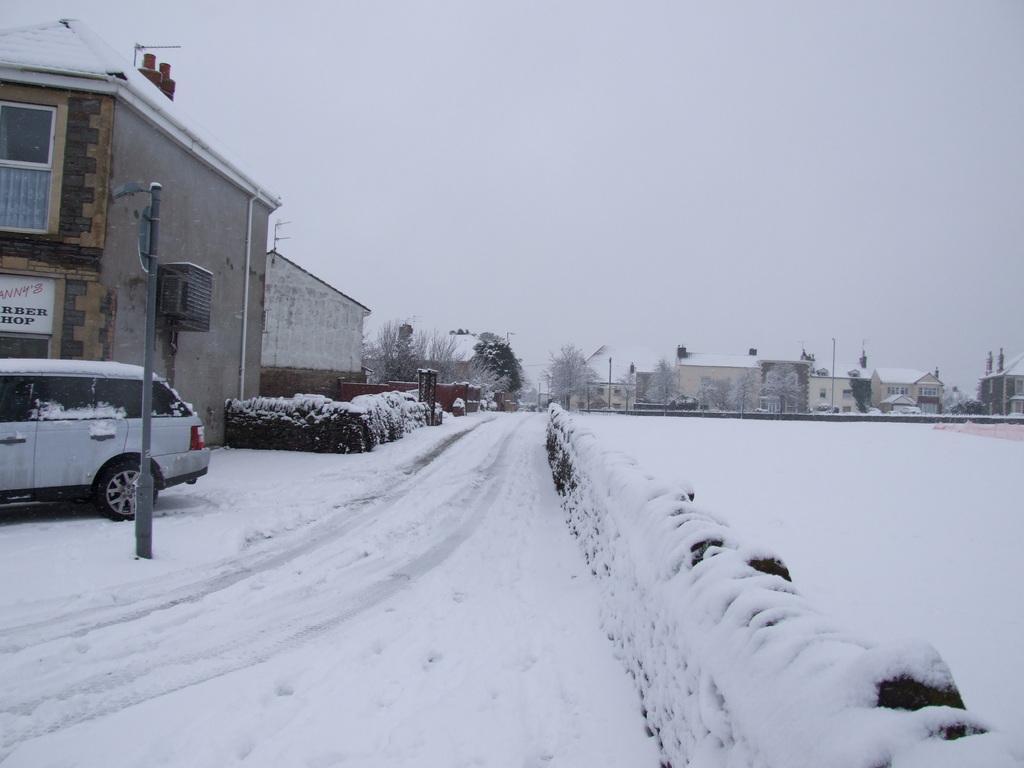Could you give a brief overview of what you see in this image? In this image in the front there is snow on the ground. On the left side there is a pole, there is a car and there are buildings and there are plants. In the background there are trees and buildings and on the top of the buildings there is snow. On the left side on the building there is a board with some text written on it. 